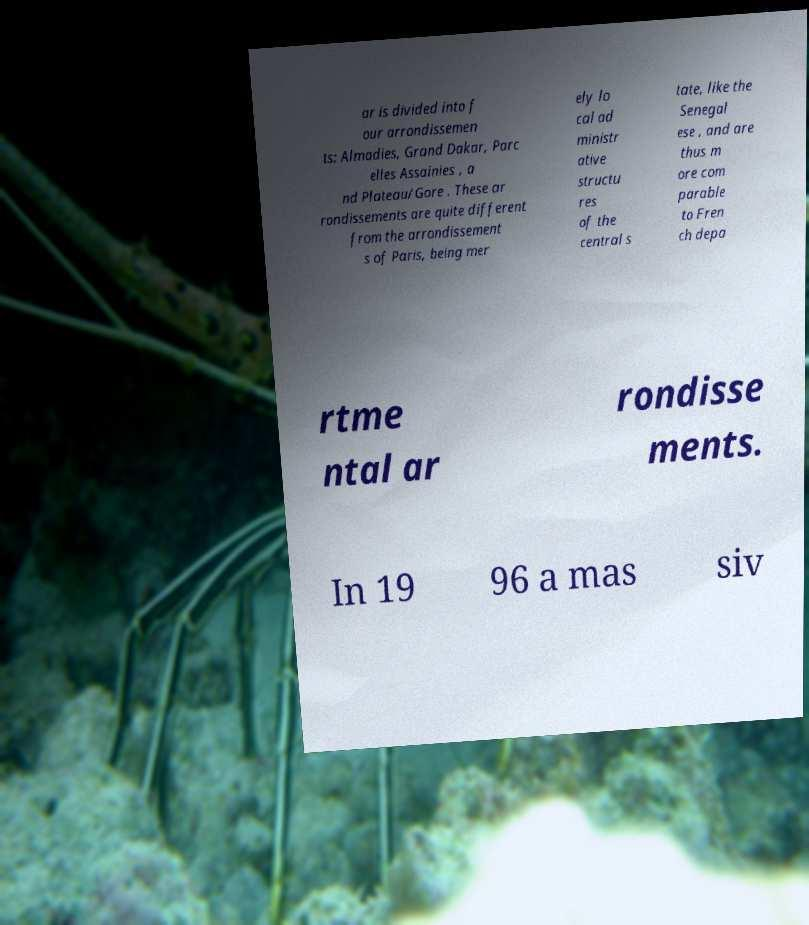There's text embedded in this image that I need extracted. Can you transcribe it verbatim? ar is divided into f our arrondissemen ts: Almadies, Grand Dakar, Parc elles Assainies , a nd Plateau/Gore . These ar rondissements are quite different from the arrondissement s of Paris, being mer ely lo cal ad ministr ative structu res of the central s tate, like the Senegal ese , and are thus m ore com parable to Fren ch depa rtme ntal ar rondisse ments. In 19 96 a mas siv 